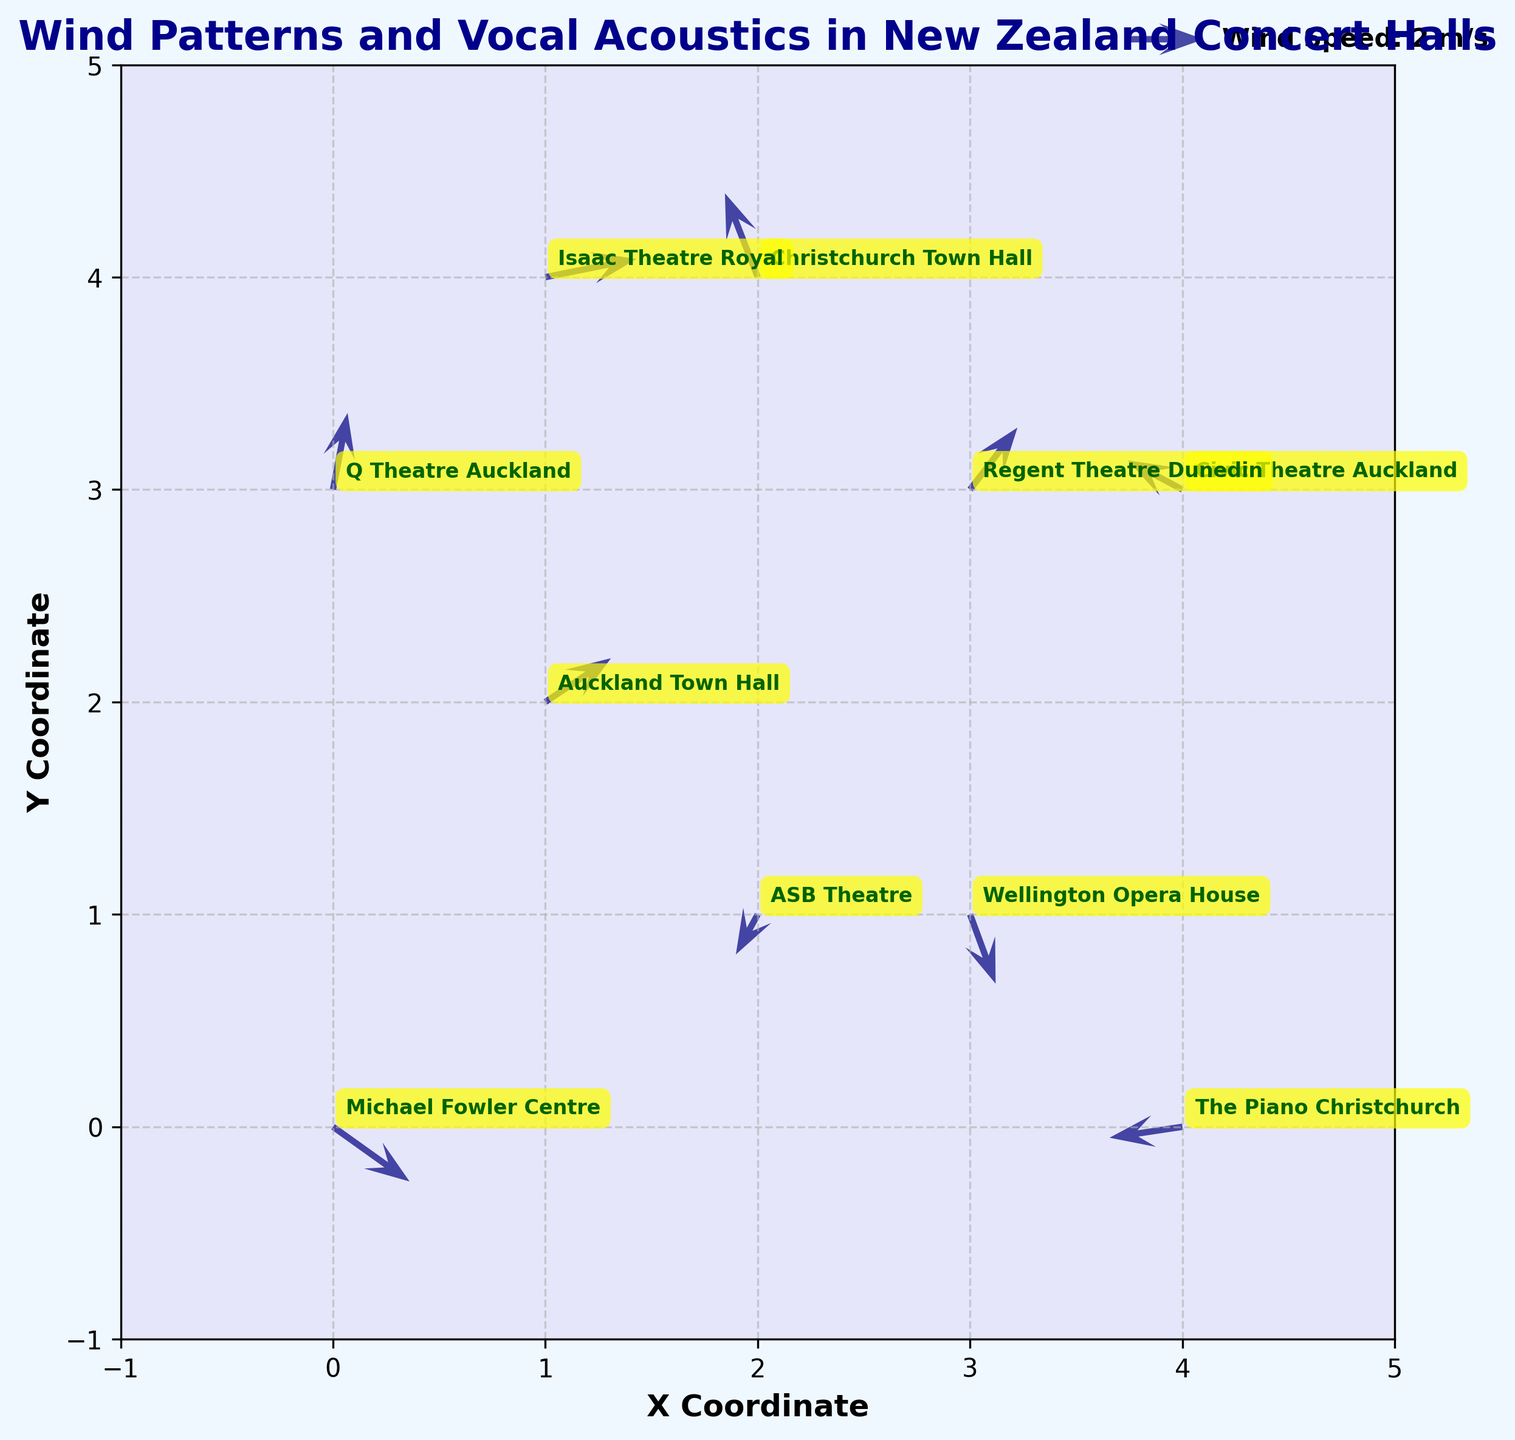What's the title of the figure? The title of the figure is placed at the top-center and is in dark blue, bold font. It reads as "Wind Patterns and Vocal Acoustics in New Zealand Concert Halls"
Answer: Wind Patterns and Vocal Acoustics in New Zealand Concert Halls What colors are used for the wind vectors and venue labels? The wind vectors are colored navy with an alpha transparency of 0.7. The venue labels are in dark green text within yellow boxes with rounded corners.
Answer: Navy for vectors, dark green text within yellow boxes for labels How many data points are represented in this figure? The data points correspond to the arrows in the quiver plot, each accompanied by a venue label. By counting these elements, we find there are ten data points.
Answer: 10 What are the x-coordinate and y-coordinate ranges used in the plot? The x-coordinate ranges from -1 to 5 on the horizontal axis, and the y-coordinate ranges from -1 to 5 on the vertical axis, as indicated by the limits set on these axes.
Answer: (-1, 5) for both x and y Which venue has the largest wind vector magnitude? To find the largest wind vector magnitude, calculate the magnitudes using the formula sqrt(u^2 + v^2) for each venue. Michael Fowler Centre has the magnitude: sqrt(2.1^2 + (-1.5)^2) ≈ 2.6, which is the largest when compared to others.
Answer: Michael Fowler Centre What is the average y-coordinate of all venues? Sum the y-coordinates: 0 + 2 + 4 + 1 + 3 + 4 + 1 + 3 + 0 + 3 = 21, and divide by the number of venues, which is 10: 21 / 10 = 2.1
Answer: 2.1 Which venue is labeled closest to the origin? The origin is (0,0). Calculate the Euclidean distance for each venue from the origin. Michael Fowler Centre is at (0,0), which is directly at the origin.
Answer: Michael Fowler Centre Does any venue have a negative x-coordinate? Inspect the x-coordinates for any negative values. In this dataset, no venue has an x-coordinate that is negative.
Answer: No What are the components (u and v) of the wind vector at Christchurch Town Hall? Christchurch Town Hall is labeled at coordinates (2, 4). Its wind vector components are u = -0.9 and v = 2.3.
Answer: u = -0.9, v = 2.3 Which venue has a wind vector pointing primarily upward? A primarily upward vector has a high positive v value. Regent Theatre Dunedin at (3, 3) has u = 1.3 and v = 1.7, which has a significant upward component compared to others.
Answer: Regent Theatre Dunedin 